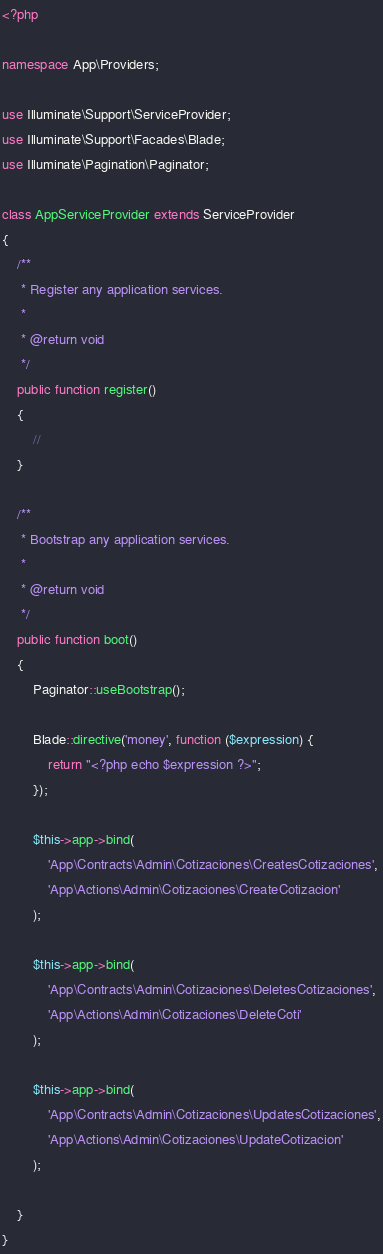Convert code to text. <code><loc_0><loc_0><loc_500><loc_500><_PHP_><?php

namespace App\Providers;

use Illuminate\Support\ServiceProvider;
use Illuminate\Support\Facades\Blade;
use Illuminate\Pagination\Paginator;

class AppServiceProvider extends ServiceProvider
{
    /**
     * Register any application services.
     *
     * @return void
     */
    public function register()
    {
        //
    }

    /**
     * Bootstrap any application services.
     *
     * @return void
     */
    public function boot()
    {
        Paginator::useBootstrap();

        Blade::directive('money', function ($expression) {
            return "<?php echo $expression ?>";
        });

        $this->app->bind(
            'App\Contracts\Admin\Cotizaciones\CreatesCotizaciones',
            'App\Actions\Admin\Cotizaciones\CreateCotizacion'
        );

        $this->app->bind(
            'App\Contracts\Admin\Cotizaciones\DeletesCotizaciones',
            'App\Actions\Admin\Cotizaciones\DeleteCoti'
        );

        $this->app->bind(
            'App\Contracts\Admin\Cotizaciones\UpdatesCotizaciones',
            'App\Actions\Admin\Cotizaciones\UpdateCotizacion'
        );

    }
}
</code> 